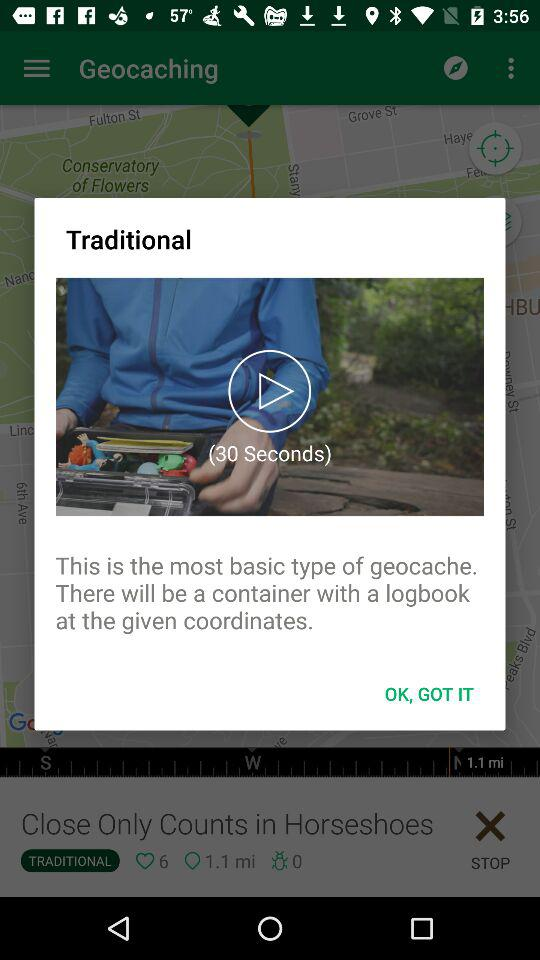What is the given distance? The given distance is 1.1 miles. 